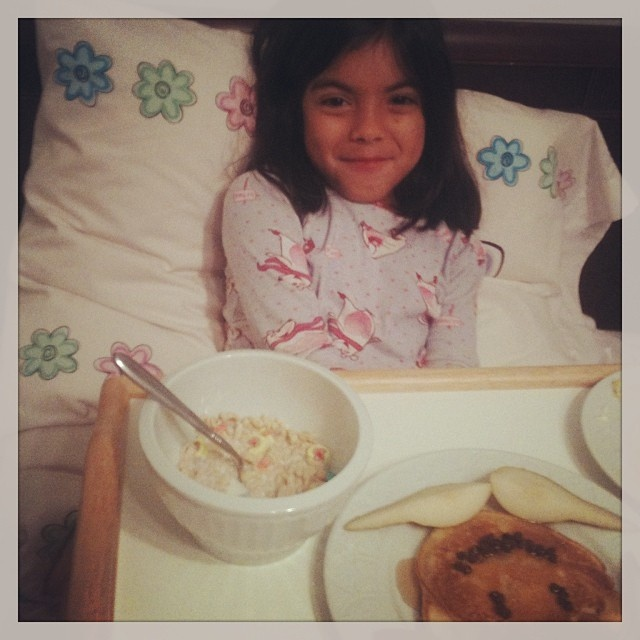Describe the objects in this image and their specific colors. I can see bed in darkgray, tan, and gray tones, people in darkgray, black, brown, and maroon tones, dining table in darkgray, tan, lightgray, and gray tones, bowl in darkgray, tan, and lightgray tones, and spoon in darkgray, gray, and tan tones in this image. 